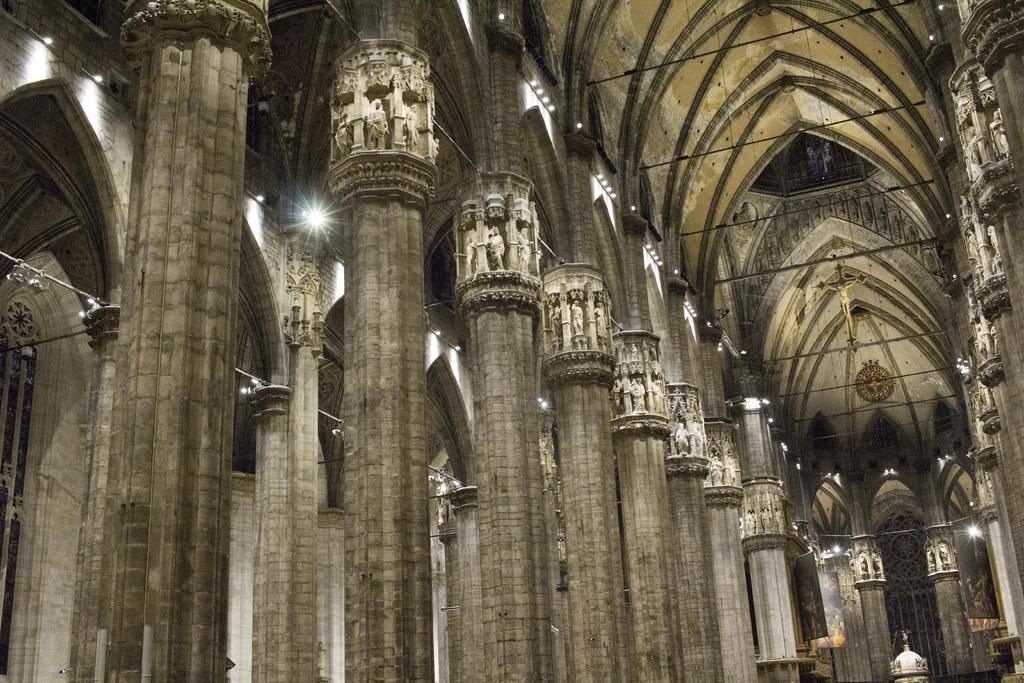What type of building is shown in the image? The image is of the inside of a church. What architectural features can be seen on both sides of the image? There are pillars on both the right and left sides of the image. Can you describe the lighting inside the church? There are lights visible inside the church. What type of sail can be seen in the image? There is no sail present in the image; it is a picture of the inside of a church. 